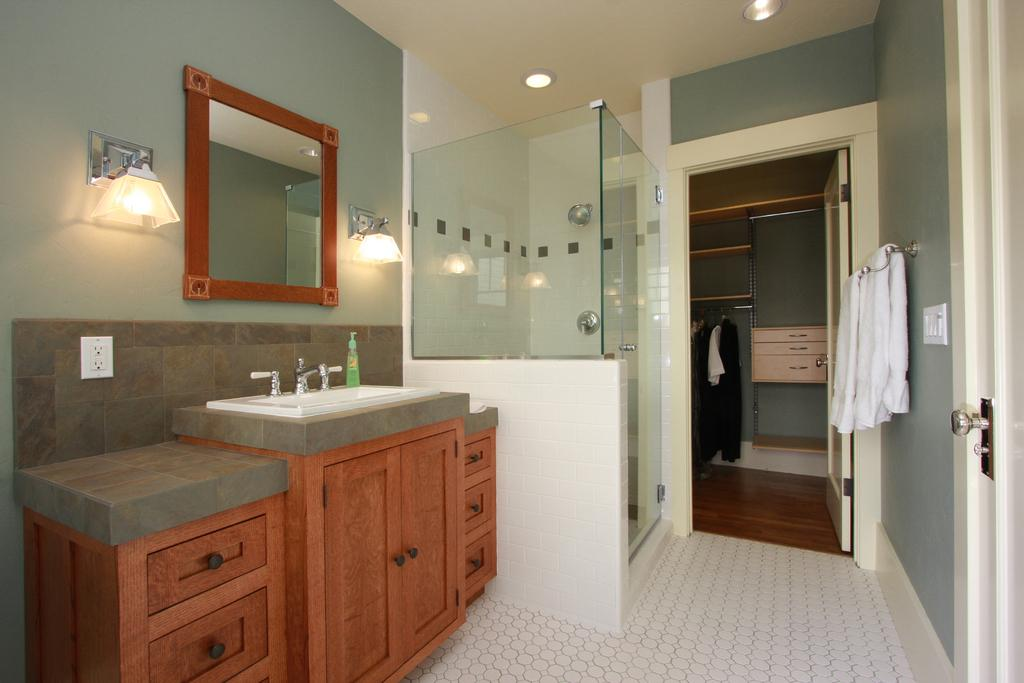What type of space is depicted in the image? The image shows an inner view of a room. What lighting source is present in the room? There are electric lights in the room. How are clothes stored in the room? Clothes are hanged on hangers in the room. What type of furniture is present in the room? There are cupboards in the room. What is the purpose of the sink in the room? A sink is present in the room, likely for washing hands or cleaning purposes. What are the taps used for in the room? Taps are visible in the room, which are used for controlling the flow of water in the sink. What items can be found in the room for daily use? Daily essentials are in the room. What is used for personal grooming in the room? A mirror is in the room. How many servants are present in the room, and what are they doing? There are no servants present in the room. Is there a judge in the room, and what is their role? There is no judge present in the room. What type of silverware can be seen in the room? There is no silverware visible in the room. 